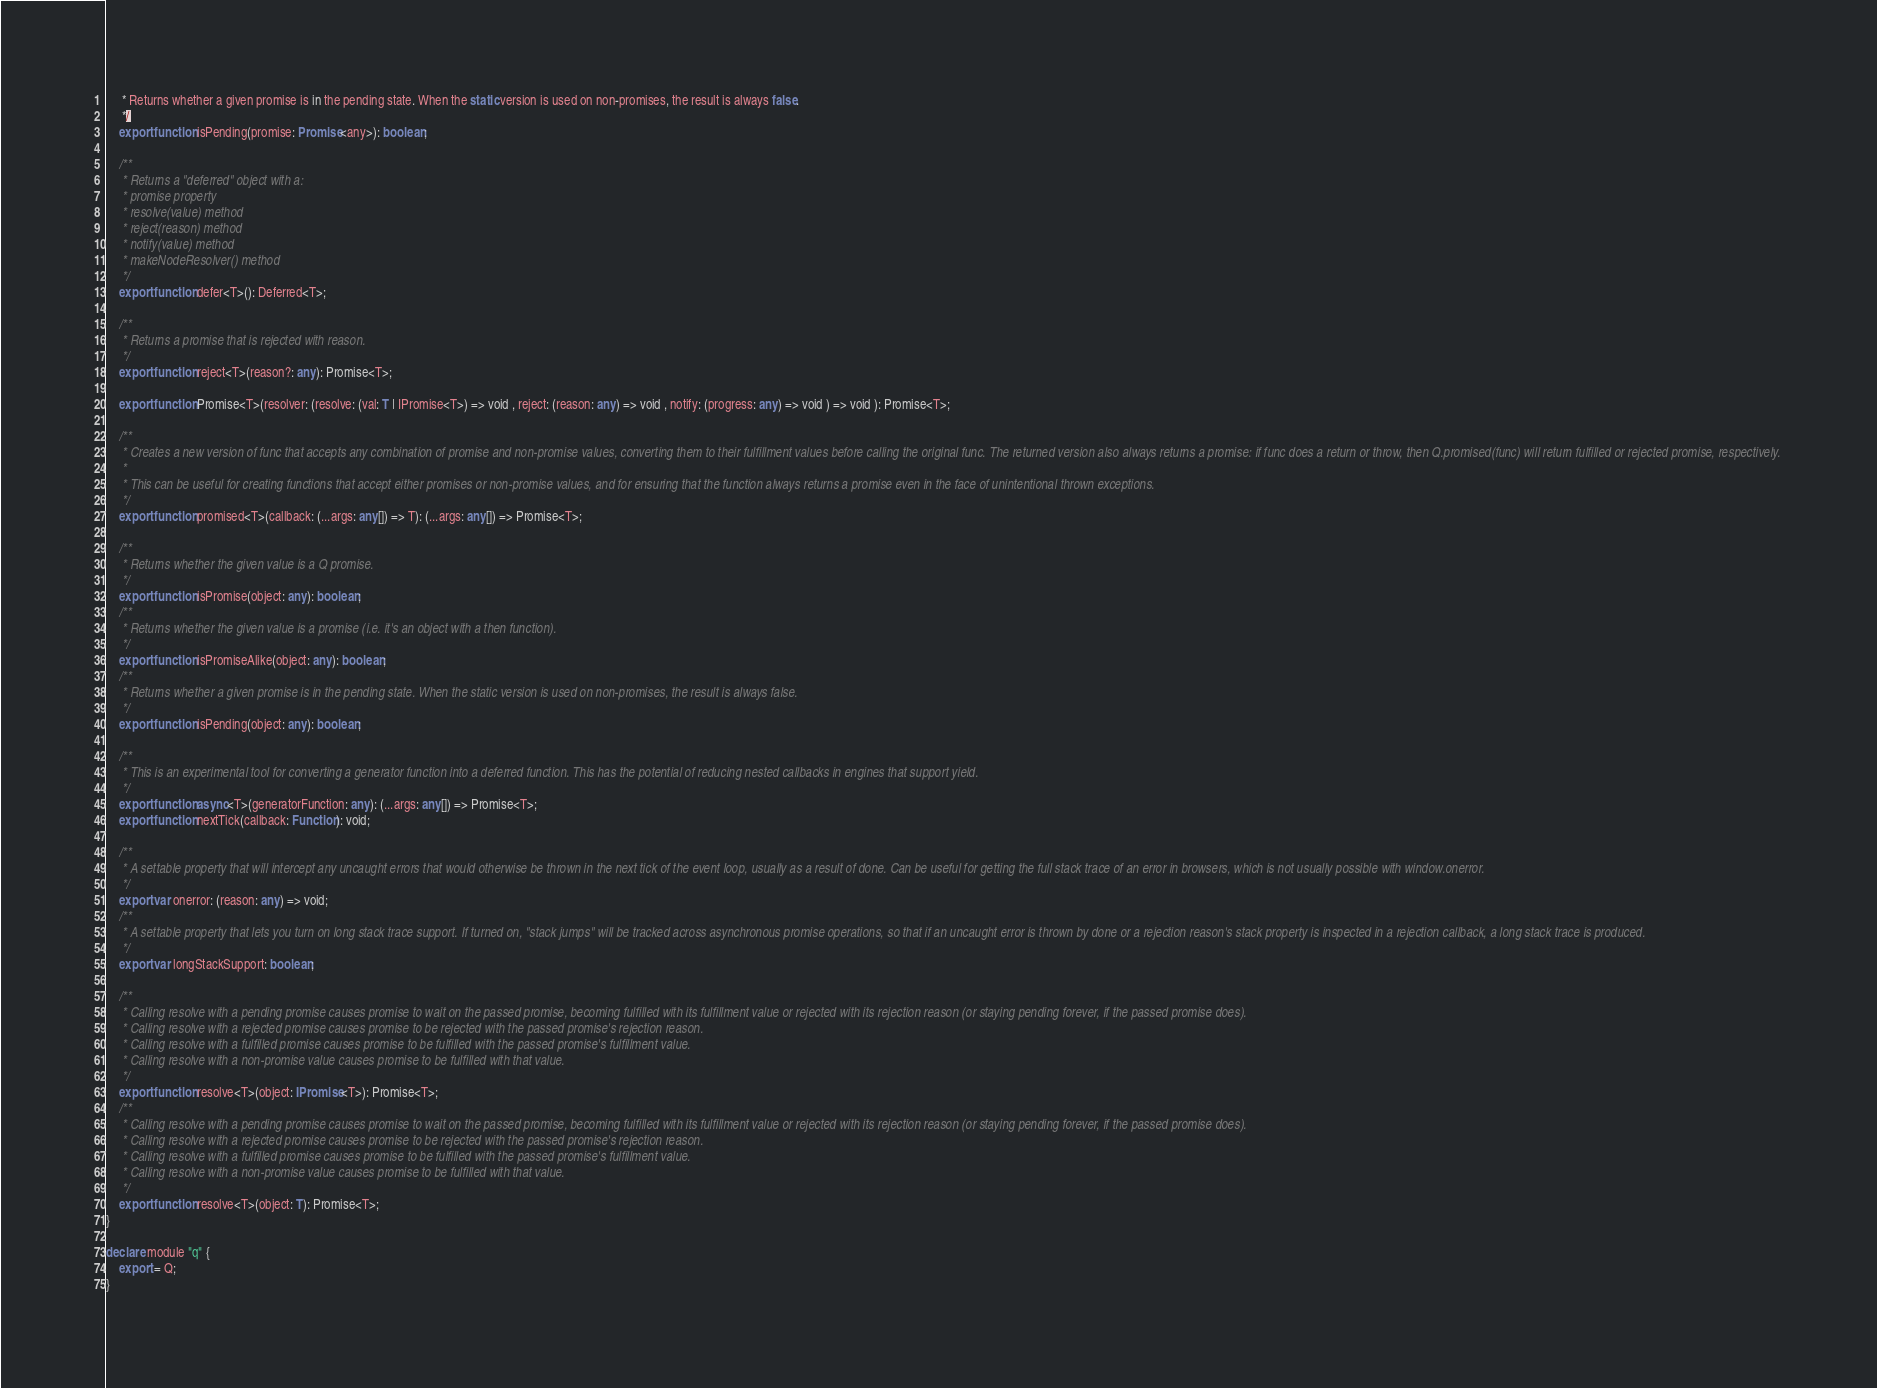<code> <loc_0><loc_0><loc_500><loc_500><_TypeScript_>     * Returns whether a given promise is in the pending state. When the static version is used on non-promises, the result is always false.
     */
    export function isPending(promise: Promise<any>): boolean;

    /**
     * Returns a "deferred" object with a:
     * promise property
     * resolve(value) method
     * reject(reason) method
     * notify(value) method
     * makeNodeResolver() method
     */
    export function defer<T>(): Deferred<T>;

    /**
     * Returns a promise that is rejected with reason.
     */
    export function reject<T>(reason?: any): Promise<T>;

    export function Promise<T>(resolver: (resolve: (val: T | IPromise<T>) => void , reject: (reason: any) => void , notify: (progress: any) => void ) => void ): Promise<T>;

    /**
     * Creates a new version of func that accepts any combination of promise and non-promise values, converting them to their fulfillment values before calling the original func. The returned version also always returns a promise: if func does a return or throw, then Q.promised(func) will return fulfilled or rejected promise, respectively.
     *
     * This can be useful for creating functions that accept either promises or non-promise values, and for ensuring that the function always returns a promise even in the face of unintentional thrown exceptions.
     */
    export function promised<T>(callback: (...args: any[]) => T): (...args: any[]) => Promise<T>;

    /**
     * Returns whether the given value is a Q promise.
     */
    export function isPromise(object: any): boolean;
    /**
     * Returns whether the given value is a promise (i.e. it's an object with a then function).
     */
    export function isPromiseAlike(object: any): boolean;
    /**
     * Returns whether a given promise is in the pending state. When the static version is used on non-promises, the result is always false.
     */
    export function isPending(object: any): boolean;

    /**
     * This is an experimental tool for converting a generator function into a deferred function. This has the potential of reducing nested callbacks in engines that support yield.
     */
    export function async<T>(generatorFunction: any): (...args: any[]) => Promise<T>;
    export function nextTick(callback: Function): void;

    /**
     * A settable property that will intercept any uncaught errors that would otherwise be thrown in the next tick of the event loop, usually as a result of done. Can be useful for getting the full stack trace of an error in browsers, which is not usually possible with window.onerror.
     */
    export var onerror: (reason: any) => void;
    /**
     * A settable property that lets you turn on long stack trace support. If turned on, "stack jumps" will be tracked across asynchronous promise operations, so that if an uncaught error is thrown by done or a rejection reason's stack property is inspected in a rejection callback, a long stack trace is produced.
     */
    export var longStackSupport: boolean;

    /**
     * Calling resolve with a pending promise causes promise to wait on the passed promise, becoming fulfilled with its fulfillment value or rejected with its rejection reason (or staying pending forever, if the passed promise does).
     * Calling resolve with a rejected promise causes promise to be rejected with the passed promise's rejection reason.
     * Calling resolve with a fulfilled promise causes promise to be fulfilled with the passed promise's fulfillment value.
     * Calling resolve with a non-promise value causes promise to be fulfilled with that value.
     */
    export function resolve<T>(object: IPromise<T>): Promise<T>;
    /**
     * Calling resolve with a pending promise causes promise to wait on the passed promise, becoming fulfilled with its fulfillment value or rejected with its rejection reason (or staying pending forever, if the passed promise does).
     * Calling resolve with a rejected promise causes promise to be rejected with the passed promise's rejection reason.
     * Calling resolve with a fulfilled promise causes promise to be fulfilled with the passed promise's fulfillment value.
     * Calling resolve with a non-promise value causes promise to be fulfilled with that value.
     */
    export function resolve<T>(object: T): Promise<T>;
}

declare module "q" {
    export = Q;
}</code> 